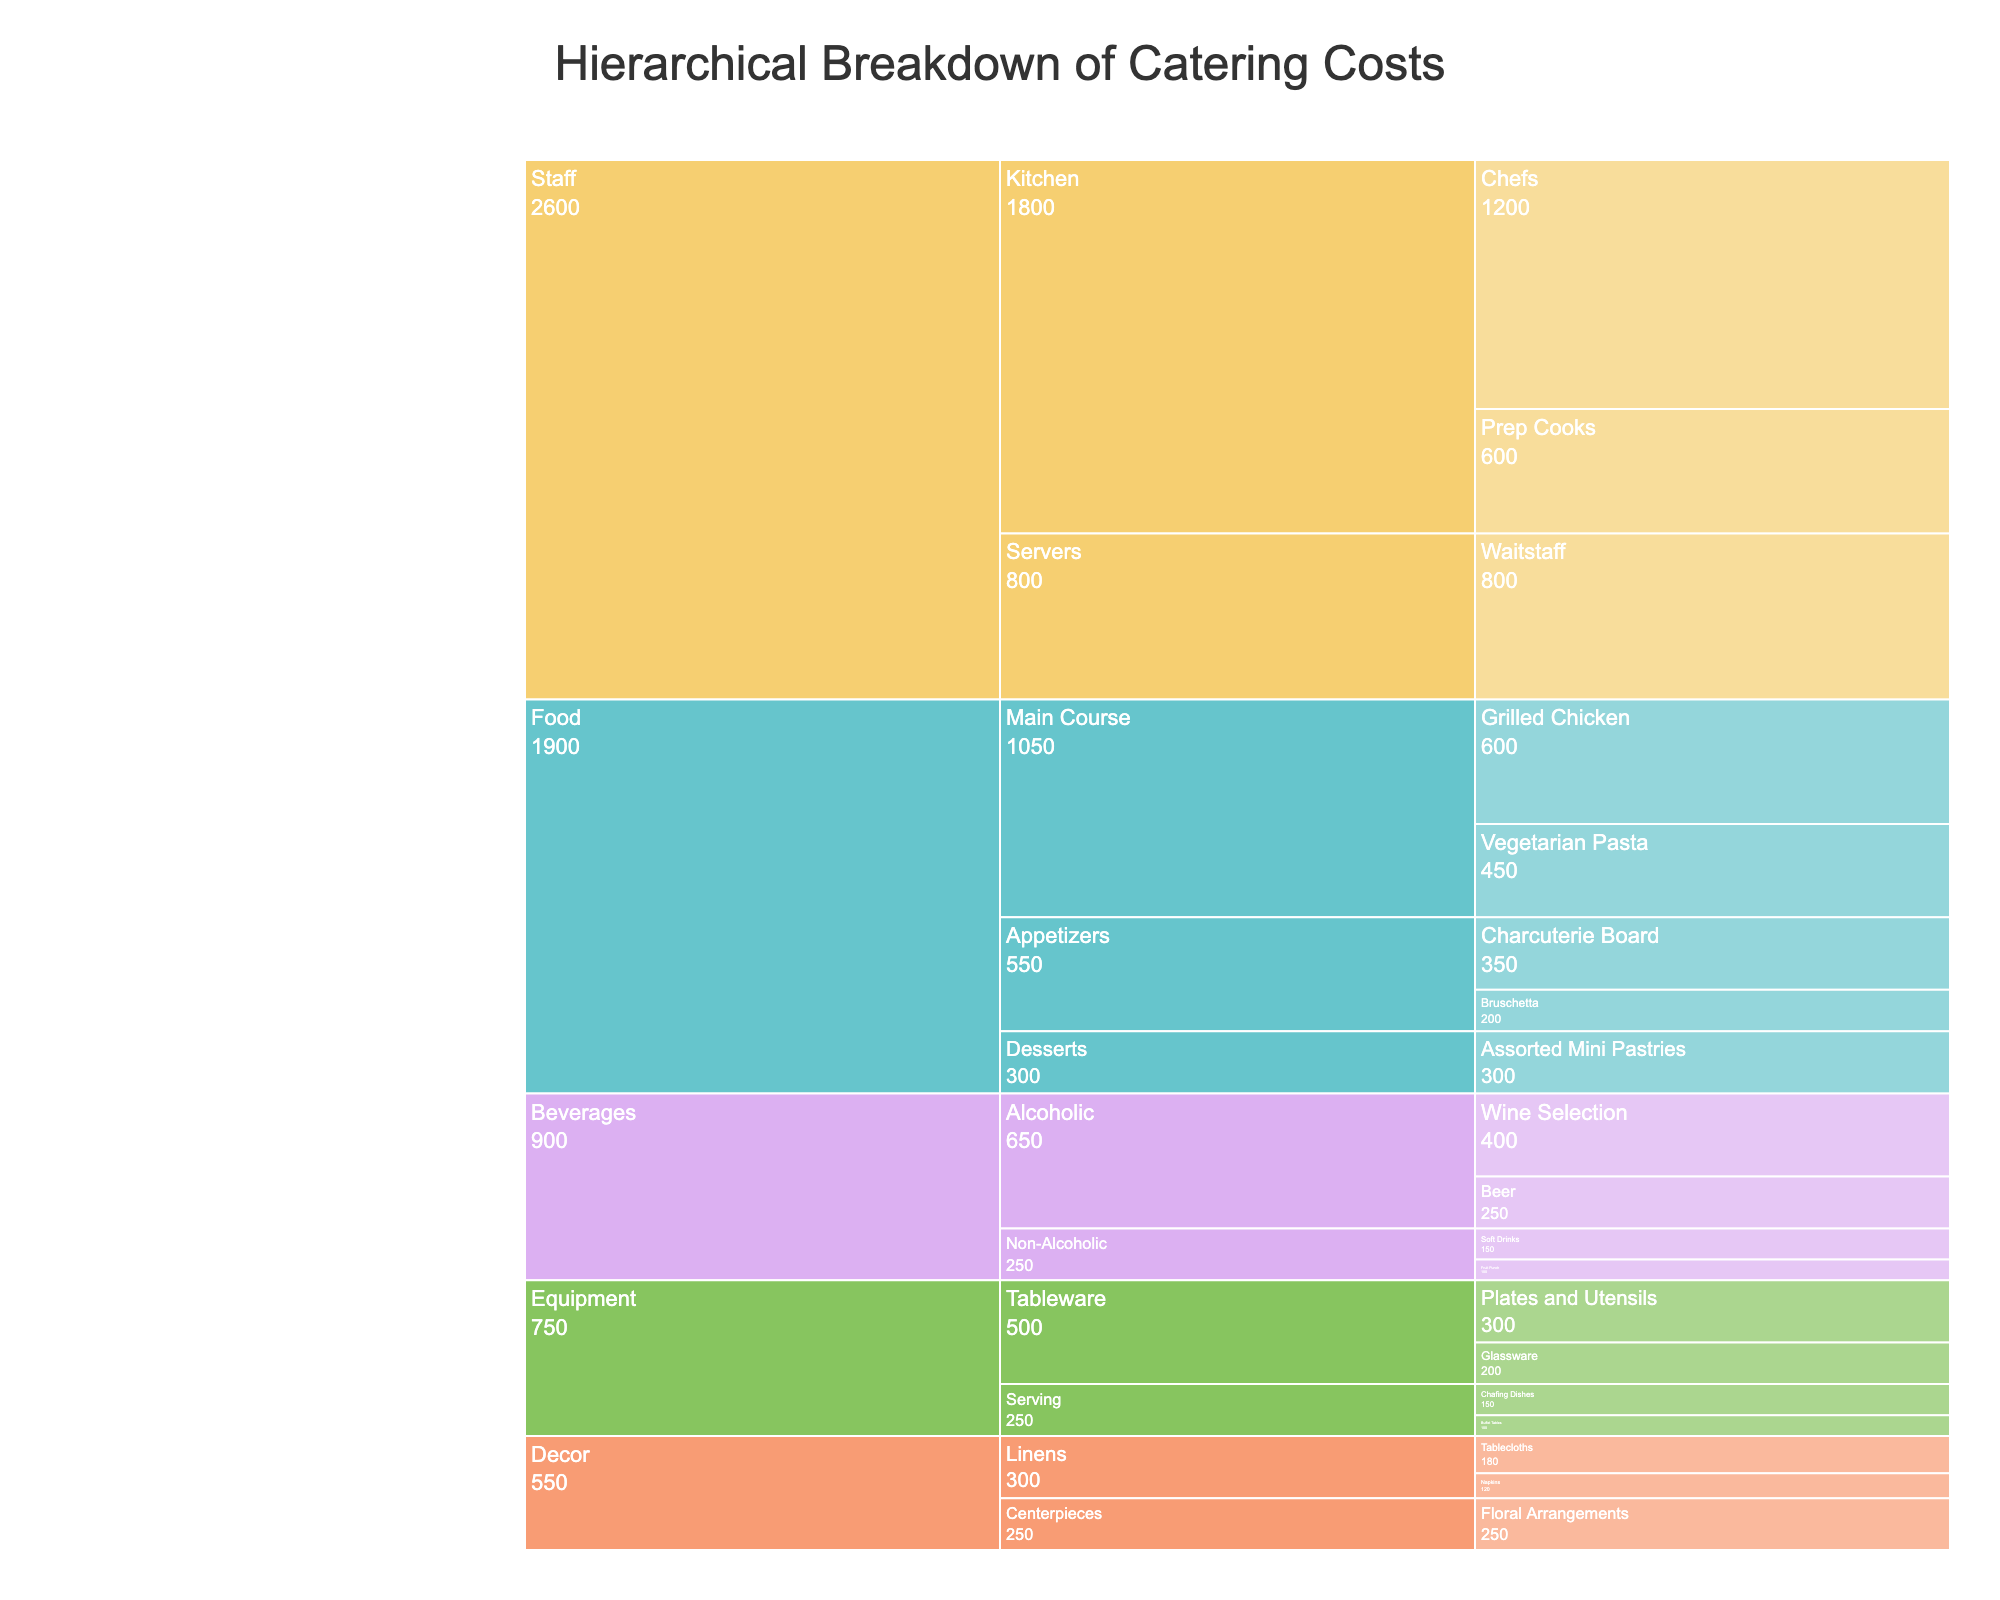what's the title of the chart? The title of the chart is displayed at the top. It reads 'Hierarchical Breakdown of Catering Costs' in a larger and distinct font size to indicate its significance.
Answer: Hierarchical Breakdown of Catering Costs how much is spent on non-alcoholic beverages? To find the total cost of non-alcoholic beverages, look under the 'Beverages' category and sum the costs of 'Soft Drinks' and 'Fruit Punch'. This means adding $150 for Soft Drinks and $100 for Fruit Punch.
Answer: 250 which category has the highest cost? By examining the aggregated costs, the 'Staff' category stands out with $800 for Waitstaff, $1200 for Chefs, and $600 for Prep Cooks, summing up to $2600, which is higher than any other category.
Answer: Staff what is the total cost for the Equipment category? The Equipment category includes 'Tableware' (Plates and Utensils: $300, Glassware: $200) and 'Serving' (Chafing Dishes: $150, Buffet Tables: $100). Adding all these costs together gives $750.
Answer: 750 which dessert item is included in the catering costs, and how much does it cost? Under the 'Food' category, navigate to 'Desserts'. The item listed is 'Assorted Mini Pastries' which costs $300.
Answer: Assorted Mini Pastries, 300 how does the cost of staff compare to the cost of food? Summing the staff costs (Waitstaff: $800, Chefs: $1200, Prep Cooks: $600) yields $2600. Summing the food costs (Charcuterie Board: $350, Bruschetta: $200, Grilled Chicken: $600, Vegetarian Pasta: $450, Assorted Mini Pastries: $300) yields $1900. Hence, staff costs are significantly higher.
Answer: Staff is higher what is the combined cost for appetizers and desserts? Within the 'Food' category, sum up the 'Appetizers' (Charcuterie Board: $350, Bruschetta: $200) and 'Desserts' (Assorted Mini Pastries: $300). So, $350 + $200 + $300 = $850.
Answer: 850 which subcategory within beverages has a higher cost, alcoholic or non-alcoholic? In the 'Beverages' category, sum the costs for 'Alcoholic' (Wine Selection: $400, Beer: $250) and 'Non-Alcoholic' (Soft Drinks: $150, Fruit Punch: $100). Alcoholic is $650 while Non-Alcoholic is $250. Hence, Alcoholic is higher.
Answer: Alcoholic what is the most expensive item in the chart? The most expensive item can be identified as 'Chefs' under the 'Staff' category with a cost of $1200.
Answer: Chefs what is the total cost for the decor category? The Decor category includes 'Linens' (Tablecloths: $180, Napkins: $120) and 'Centerpieces' (Floral Arrangements: $250). Summing these gives $180 + $120 + $250 = $550.
Answer: 550 